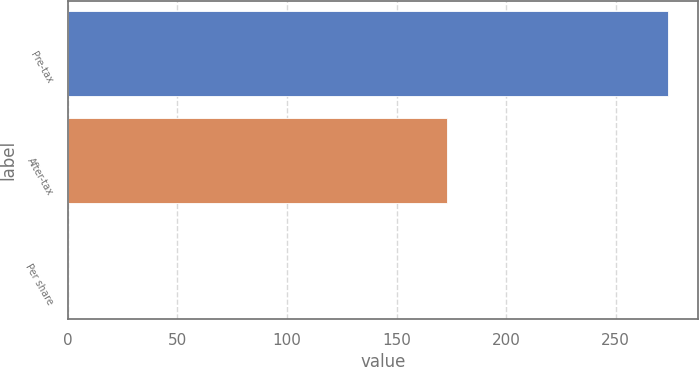<chart> <loc_0><loc_0><loc_500><loc_500><bar_chart><fcel>Pre-tax<fcel>After-tax<fcel>Per share<nl><fcel>274<fcel>173<fcel>0.11<nl></chart> 